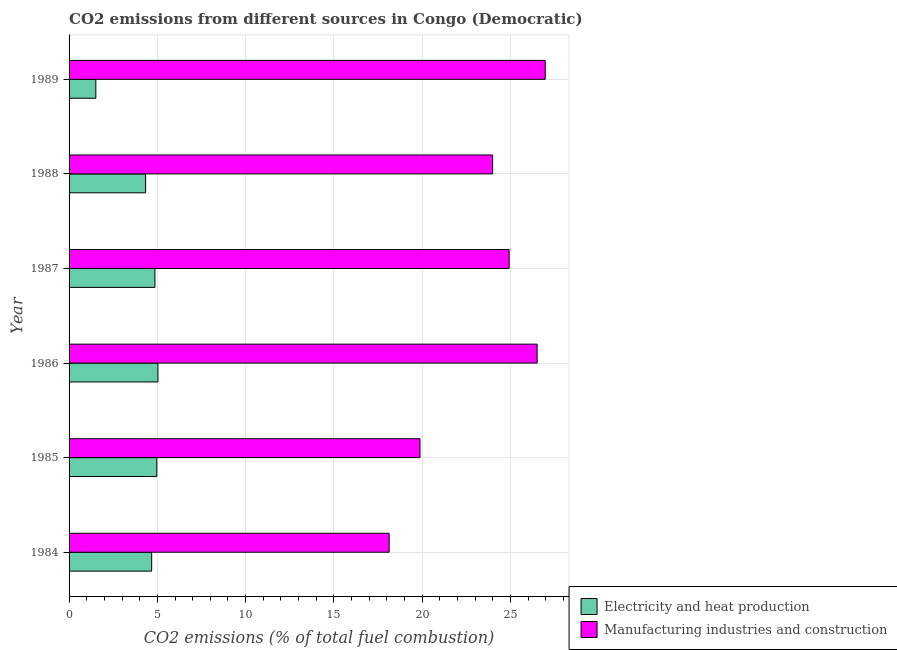How many groups of bars are there?
Offer a very short reply. 6. Are the number of bars per tick equal to the number of legend labels?
Provide a short and direct response. Yes. How many bars are there on the 3rd tick from the top?
Offer a terse response. 2. What is the co2 emissions due to electricity and heat production in 1989?
Provide a succinct answer. 1.52. Across all years, what is the maximum co2 emissions due to manufacturing industries?
Your response must be concise. 26.97. Across all years, what is the minimum co2 emissions due to electricity and heat production?
Offer a terse response. 1.52. What is the total co2 emissions due to manufacturing industries in the graph?
Your response must be concise. 140.4. What is the difference between the co2 emissions due to manufacturing industries in 1984 and that in 1989?
Give a very brief answer. -8.84. What is the difference between the co2 emissions due to electricity and heat production in 1989 and the co2 emissions due to manufacturing industries in 1988?
Your answer should be very brief. -22.47. What is the average co2 emissions due to manufacturing industries per year?
Give a very brief answer. 23.4. In the year 1986, what is the difference between the co2 emissions due to manufacturing industries and co2 emissions due to electricity and heat production?
Ensure brevity in your answer.  21.48. In how many years, is the co2 emissions due to electricity and heat production greater than 3 %?
Offer a very short reply. 5. What is the ratio of the co2 emissions due to manufacturing industries in 1984 to that in 1987?
Your answer should be very brief. 0.73. Is the co2 emissions due to manufacturing industries in 1988 less than that in 1989?
Provide a short and direct response. Yes. What is the difference between the highest and the second highest co2 emissions due to manufacturing industries?
Keep it short and to the point. 0.46. What is the difference between the highest and the lowest co2 emissions due to manufacturing industries?
Offer a terse response. 8.84. In how many years, is the co2 emissions due to manufacturing industries greater than the average co2 emissions due to manufacturing industries taken over all years?
Provide a succinct answer. 4. What does the 1st bar from the top in 1989 represents?
Offer a very short reply. Manufacturing industries and construction. What does the 2nd bar from the bottom in 1984 represents?
Your answer should be compact. Manufacturing industries and construction. How many bars are there?
Your answer should be very brief. 12. Are all the bars in the graph horizontal?
Your response must be concise. Yes. What is the difference between two consecutive major ticks on the X-axis?
Offer a very short reply. 5. Are the values on the major ticks of X-axis written in scientific E-notation?
Offer a terse response. No. Does the graph contain any zero values?
Keep it short and to the point. No. Does the graph contain grids?
Make the answer very short. Yes. Where does the legend appear in the graph?
Make the answer very short. Bottom right. What is the title of the graph?
Your response must be concise. CO2 emissions from different sources in Congo (Democratic). Does "Secondary Education" appear as one of the legend labels in the graph?
Give a very brief answer. No. What is the label or title of the X-axis?
Make the answer very short. CO2 emissions (% of total fuel combustion). What is the CO2 emissions (% of total fuel combustion) of Electricity and heat production in 1984?
Offer a terse response. 4.68. What is the CO2 emissions (% of total fuel combustion) of Manufacturing industries and construction in 1984?
Provide a short and direct response. 18.13. What is the CO2 emissions (% of total fuel combustion) in Electricity and heat production in 1985?
Your response must be concise. 4.97. What is the CO2 emissions (% of total fuel combustion) of Manufacturing industries and construction in 1985?
Offer a very short reply. 19.88. What is the CO2 emissions (% of total fuel combustion) of Electricity and heat production in 1986?
Give a very brief answer. 5.03. What is the CO2 emissions (% of total fuel combustion) in Manufacturing industries and construction in 1986?
Offer a very short reply. 26.51. What is the CO2 emissions (% of total fuel combustion) of Electricity and heat production in 1987?
Your answer should be compact. 4.86. What is the CO2 emissions (% of total fuel combustion) in Manufacturing industries and construction in 1987?
Provide a short and direct response. 24.92. What is the CO2 emissions (% of total fuel combustion) of Electricity and heat production in 1988?
Offer a terse response. 4.34. What is the CO2 emissions (% of total fuel combustion) in Manufacturing industries and construction in 1988?
Provide a short and direct response. 23.99. What is the CO2 emissions (% of total fuel combustion) in Electricity and heat production in 1989?
Give a very brief answer. 1.52. What is the CO2 emissions (% of total fuel combustion) of Manufacturing industries and construction in 1989?
Provide a succinct answer. 26.97. Across all years, what is the maximum CO2 emissions (% of total fuel combustion) of Electricity and heat production?
Give a very brief answer. 5.03. Across all years, what is the maximum CO2 emissions (% of total fuel combustion) in Manufacturing industries and construction?
Provide a short and direct response. 26.97. Across all years, what is the minimum CO2 emissions (% of total fuel combustion) of Electricity and heat production?
Keep it short and to the point. 1.52. Across all years, what is the minimum CO2 emissions (% of total fuel combustion) of Manufacturing industries and construction?
Your answer should be very brief. 18.13. What is the total CO2 emissions (% of total fuel combustion) in Electricity and heat production in the graph?
Offer a terse response. 25.39. What is the total CO2 emissions (% of total fuel combustion) in Manufacturing industries and construction in the graph?
Provide a succinct answer. 140.4. What is the difference between the CO2 emissions (% of total fuel combustion) in Electricity and heat production in 1984 and that in 1985?
Keep it short and to the point. -0.29. What is the difference between the CO2 emissions (% of total fuel combustion) of Manufacturing industries and construction in 1984 and that in 1985?
Offer a very short reply. -1.75. What is the difference between the CO2 emissions (% of total fuel combustion) in Electricity and heat production in 1984 and that in 1986?
Give a very brief answer. -0.36. What is the difference between the CO2 emissions (% of total fuel combustion) in Manufacturing industries and construction in 1984 and that in 1986?
Ensure brevity in your answer.  -8.38. What is the difference between the CO2 emissions (% of total fuel combustion) of Electricity and heat production in 1984 and that in 1987?
Make the answer very short. -0.18. What is the difference between the CO2 emissions (% of total fuel combustion) in Manufacturing industries and construction in 1984 and that in 1987?
Ensure brevity in your answer.  -6.8. What is the difference between the CO2 emissions (% of total fuel combustion) of Electricity and heat production in 1984 and that in 1988?
Your response must be concise. 0.34. What is the difference between the CO2 emissions (% of total fuel combustion) of Manufacturing industries and construction in 1984 and that in 1988?
Offer a terse response. -5.86. What is the difference between the CO2 emissions (% of total fuel combustion) in Electricity and heat production in 1984 and that in 1989?
Your answer should be compact. 3.16. What is the difference between the CO2 emissions (% of total fuel combustion) of Manufacturing industries and construction in 1984 and that in 1989?
Offer a terse response. -8.84. What is the difference between the CO2 emissions (% of total fuel combustion) in Electricity and heat production in 1985 and that in 1986?
Offer a very short reply. -0.06. What is the difference between the CO2 emissions (% of total fuel combustion) of Manufacturing industries and construction in 1985 and that in 1986?
Your answer should be very brief. -6.63. What is the difference between the CO2 emissions (% of total fuel combustion) of Electricity and heat production in 1985 and that in 1987?
Your answer should be very brief. 0.11. What is the difference between the CO2 emissions (% of total fuel combustion) in Manufacturing industries and construction in 1985 and that in 1987?
Make the answer very short. -5.05. What is the difference between the CO2 emissions (% of total fuel combustion) in Electricity and heat production in 1985 and that in 1988?
Your response must be concise. 0.63. What is the difference between the CO2 emissions (% of total fuel combustion) of Manufacturing industries and construction in 1985 and that in 1988?
Give a very brief answer. -4.11. What is the difference between the CO2 emissions (% of total fuel combustion) of Electricity and heat production in 1985 and that in 1989?
Ensure brevity in your answer.  3.45. What is the difference between the CO2 emissions (% of total fuel combustion) of Manufacturing industries and construction in 1985 and that in 1989?
Offer a very short reply. -7.09. What is the difference between the CO2 emissions (% of total fuel combustion) in Electricity and heat production in 1986 and that in 1987?
Ensure brevity in your answer.  0.17. What is the difference between the CO2 emissions (% of total fuel combustion) in Manufacturing industries and construction in 1986 and that in 1987?
Your response must be concise. 1.59. What is the difference between the CO2 emissions (% of total fuel combustion) of Electricity and heat production in 1986 and that in 1988?
Keep it short and to the point. 0.7. What is the difference between the CO2 emissions (% of total fuel combustion) in Manufacturing industries and construction in 1986 and that in 1988?
Offer a very short reply. 2.52. What is the difference between the CO2 emissions (% of total fuel combustion) of Electricity and heat production in 1986 and that in 1989?
Offer a very short reply. 3.52. What is the difference between the CO2 emissions (% of total fuel combustion) of Manufacturing industries and construction in 1986 and that in 1989?
Your response must be concise. -0.46. What is the difference between the CO2 emissions (% of total fuel combustion) in Electricity and heat production in 1987 and that in 1988?
Provide a succinct answer. 0.53. What is the difference between the CO2 emissions (% of total fuel combustion) in Manufacturing industries and construction in 1987 and that in 1988?
Ensure brevity in your answer.  0.94. What is the difference between the CO2 emissions (% of total fuel combustion) of Electricity and heat production in 1987 and that in 1989?
Ensure brevity in your answer.  3.35. What is the difference between the CO2 emissions (% of total fuel combustion) of Manufacturing industries and construction in 1987 and that in 1989?
Your response must be concise. -2.05. What is the difference between the CO2 emissions (% of total fuel combustion) of Electricity and heat production in 1988 and that in 1989?
Give a very brief answer. 2.82. What is the difference between the CO2 emissions (% of total fuel combustion) in Manufacturing industries and construction in 1988 and that in 1989?
Keep it short and to the point. -2.98. What is the difference between the CO2 emissions (% of total fuel combustion) of Electricity and heat production in 1984 and the CO2 emissions (% of total fuel combustion) of Manufacturing industries and construction in 1985?
Offer a very short reply. -15.2. What is the difference between the CO2 emissions (% of total fuel combustion) of Electricity and heat production in 1984 and the CO2 emissions (% of total fuel combustion) of Manufacturing industries and construction in 1986?
Offer a terse response. -21.83. What is the difference between the CO2 emissions (% of total fuel combustion) in Electricity and heat production in 1984 and the CO2 emissions (% of total fuel combustion) in Manufacturing industries and construction in 1987?
Make the answer very short. -20.25. What is the difference between the CO2 emissions (% of total fuel combustion) of Electricity and heat production in 1984 and the CO2 emissions (% of total fuel combustion) of Manufacturing industries and construction in 1988?
Offer a very short reply. -19.31. What is the difference between the CO2 emissions (% of total fuel combustion) in Electricity and heat production in 1984 and the CO2 emissions (% of total fuel combustion) in Manufacturing industries and construction in 1989?
Ensure brevity in your answer.  -22.29. What is the difference between the CO2 emissions (% of total fuel combustion) in Electricity and heat production in 1985 and the CO2 emissions (% of total fuel combustion) in Manufacturing industries and construction in 1986?
Give a very brief answer. -21.54. What is the difference between the CO2 emissions (% of total fuel combustion) of Electricity and heat production in 1985 and the CO2 emissions (% of total fuel combustion) of Manufacturing industries and construction in 1987?
Give a very brief answer. -19.96. What is the difference between the CO2 emissions (% of total fuel combustion) of Electricity and heat production in 1985 and the CO2 emissions (% of total fuel combustion) of Manufacturing industries and construction in 1988?
Give a very brief answer. -19.02. What is the difference between the CO2 emissions (% of total fuel combustion) of Electricity and heat production in 1985 and the CO2 emissions (% of total fuel combustion) of Manufacturing industries and construction in 1989?
Offer a terse response. -22. What is the difference between the CO2 emissions (% of total fuel combustion) in Electricity and heat production in 1986 and the CO2 emissions (% of total fuel combustion) in Manufacturing industries and construction in 1987?
Your answer should be very brief. -19.89. What is the difference between the CO2 emissions (% of total fuel combustion) in Electricity and heat production in 1986 and the CO2 emissions (% of total fuel combustion) in Manufacturing industries and construction in 1988?
Your response must be concise. -18.95. What is the difference between the CO2 emissions (% of total fuel combustion) of Electricity and heat production in 1986 and the CO2 emissions (% of total fuel combustion) of Manufacturing industries and construction in 1989?
Your answer should be compact. -21.94. What is the difference between the CO2 emissions (% of total fuel combustion) in Electricity and heat production in 1987 and the CO2 emissions (% of total fuel combustion) in Manufacturing industries and construction in 1988?
Ensure brevity in your answer.  -19.13. What is the difference between the CO2 emissions (% of total fuel combustion) of Electricity and heat production in 1987 and the CO2 emissions (% of total fuel combustion) of Manufacturing industries and construction in 1989?
Keep it short and to the point. -22.11. What is the difference between the CO2 emissions (% of total fuel combustion) in Electricity and heat production in 1988 and the CO2 emissions (% of total fuel combustion) in Manufacturing industries and construction in 1989?
Offer a terse response. -22.63. What is the average CO2 emissions (% of total fuel combustion) in Electricity and heat production per year?
Keep it short and to the point. 4.23. What is the average CO2 emissions (% of total fuel combustion) of Manufacturing industries and construction per year?
Offer a terse response. 23.4. In the year 1984, what is the difference between the CO2 emissions (% of total fuel combustion) of Electricity and heat production and CO2 emissions (% of total fuel combustion) of Manufacturing industries and construction?
Provide a succinct answer. -13.45. In the year 1985, what is the difference between the CO2 emissions (% of total fuel combustion) in Electricity and heat production and CO2 emissions (% of total fuel combustion) in Manufacturing industries and construction?
Provide a short and direct response. -14.91. In the year 1986, what is the difference between the CO2 emissions (% of total fuel combustion) in Electricity and heat production and CO2 emissions (% of total fuel combustion) in Manufacturing industries and construction?
Keep it short and to the point. -21.48. In the year 1987, what is the difference between the CO2 emissions (% of total fuel combustion) in Electricity and heat production and CO2 emissions (% of total fuel combustion) in Manufacturing industries and construction?
Your response must be concise. -20.06. In the year 1988, what is the difference between the CO2 emissions (% of total fuel combustion) in Electricity and heat production and CO2 emissions (% of total fuel combustion) in Manufacturing industries and construction?
Make the answer very short. -19.65. In the year 1989, what is the difference between the CO2 emissions (% of total fuel combustion) of Electricity and heat production and CO2 emissions (% of total fuel combustion) of Manufacturing industries and construction?
Your response must be concise. -25.45. What is the ratio of the CO2 emissions (% of total fuel combustion) of Electricity and heat production in 1984 to that in 1985?
Provide a succinct answer. 0.94. What is the ratio of the CO2 emissions (% of total fuel combustion) of Manufacturing industries and construction in 1984 to that in 1985?
Offer a very short reply. 0.91. What is the ratio of the CO2 emissions (% of total fuel combustion) of Electricity and heat production in 1984 to that in 1986?
Provide a short and direct response. 0.93. What is the ratio of the CO2 emissions (% of total fuel combustion) of Manufacturing industries and construction in 1984 to that in 1986?
Provide a succinct answer. 0.68. What is the ratio of the CO2 emissions (% of total fuel combustion) in Electricity and heat production in 1984 to that in 1987?
Ensure brevity in your answer.  0.96. What is the ratio of the CO2 emissions (% of total fuel combustion) of Manufacturing industries and construction in 1984 to that in 1987?
Keep it short and to the point. 0.73. What is the ratio of the CO2 emissions (% of total fuel combustion) in Electricity and heat production in 1984 to that in 1988?
Offer a terse response. 1.08. What is the ratio of the CO2 emissions (% of total fuel combustion) of Manufacturing industries and construction in 1984 to that in 1988?
Offer a terse response. 0.76. What is the ratio of the CO2 emissions (% of total fuel combustion) of Electricity and heat production in 1984 to that in 1989?
Your response must be concise. 3.09. What is the ratio of the CO2 emissions (% of total fuel combustion) in Manufacturing industries and construction in 1984 to that in 1989?
Your answer should be very brief. 0.67. What is the ratio of the CO2 emissions (% of total fuel combustion) of Electricity and heat production in 1985 to that in 1986?
Provide a short and direct response. 0.99. What is the ratio of the CO2 emissions (% of total fuel combustion) of Manufacturing industries and construction in 1985 to that in 1986?
Your answer should be very brief. 0.75. What is the ratio of the CO2 emissions (% of total fuel combustion) in Electricity and heat production in 1985 to that in 1987?
Your answer should be compact. 1.02. What is the ratio of the CO2 emissions (% of total fuel combustion) of Manufacturing industries and construction in 1985 to that in 1987?
Ensure brevity in your answer.  0.8. What is the ratio of the CO2 emissions (% of total fuel combustion) in Electricity and heat production in 1985 to that in 1988?
Your answer should be very brief. 1.15. What is the ratio of the CO2 emissions (% of total fuel combustion) of Manufacturing industries and construction in 1985 to that in 1988?
Offer a very short reply. 0.83. What is the ratio of the CO2 emissions (% of total fuel combustion) in Electricity and heat production in 1985 to that in 1989?
Keep it short and to the point. 3.28. What is the ratio of the CO2 emissions (% of total fuel combustion) of Manufacturing industries and construction in 1985 to that in 1989?
Your answer should be compact. 0.74. What is the ratio of the CO2 emissions (% of total fuel combustion) of Electricity and heat production in 1986 to that in 1987?
Offer a terse response. 1.03. What is the ratio of the CO2 emissions (% of total fuel combustion) in Manufacturing industries and construction in 1986 to that in 1987?
Give a very brief answer. 1.06. What is the ratio of the CO2 emissions (% of total fuel combustion) in Electricity and heat production in 1986 to that in 1988?
Your answer should be very brief. 1.16. What is the ratio of the CO2 emissions (% of total fuel combustion) of Manufacturing industries and construction in 1986 to that in 1988?
Offer a terse response. 1.11. What is the ratio of the CO2 emissions (% of total fuel combustion) in Electricity and heat production in 1986 to that in 1989?
Keep it short and to the point. 3.32. What is the ratio of the CO2 emissions (% of total fuel combustion) in Manufacturing industries and construction in 1986 to that in 1989?
Provide a succinct answer. 0.98. What is the ratio of the CO2 emissions (% of total fuel combustion) of Electricity and heat production in 1987 to that in 1988?
Your answer should be very brief. 1.12. What is the ratio of the CO2 emissions (% of total fuel combustion) of Manufacturing industries and construction in 1987 to that in 1988?
Offer a terse response. 1.04. What is the ratio of the CO2 emissions (% of total fuel combustion) in Electricity and heat production in 1987 to that in 1989?
Offer a very short reply. 3.21. What is the ratio of the CO2 emissions (% of total fuel combustion) in Manufacturing industries and construction in 1987 to that in 1989?
Provide a short and direct response. 0.92. What is the ratio of the CO2 emissions (% of total fuel combustion) in Electricity and heat production in 1988 to that in 1989?
Your response must be concise. 2.86. What is the ratio of the CO2 emissions (% of total fuel combustion) of Manufacturing industries and construction in 1988 to that in 1989?
Give a very brief answer. 0.89. What is the difference between the highest and the second highest CO2 emissions (% of total fuel combustion) of Electricity and heat production?
Ensure brevity in your answer.  0.06. What is the difference between the highest and the second highest CO2 emissions (% of total fuel combustion) of Manufacturing industries and construction?
Your answer should be very brief. 0.46. What is the difference between the highest and the lowest CO2 emissions (% of total fuel combustion) of Electricity and heat production?
Your answer should be very brief. 3.52. What is the difference between the highest and the lowest CO2 emissions (% of total fuel combustion) in Manufacturing industries and construction?
Your answer should be compact. 8.84. 